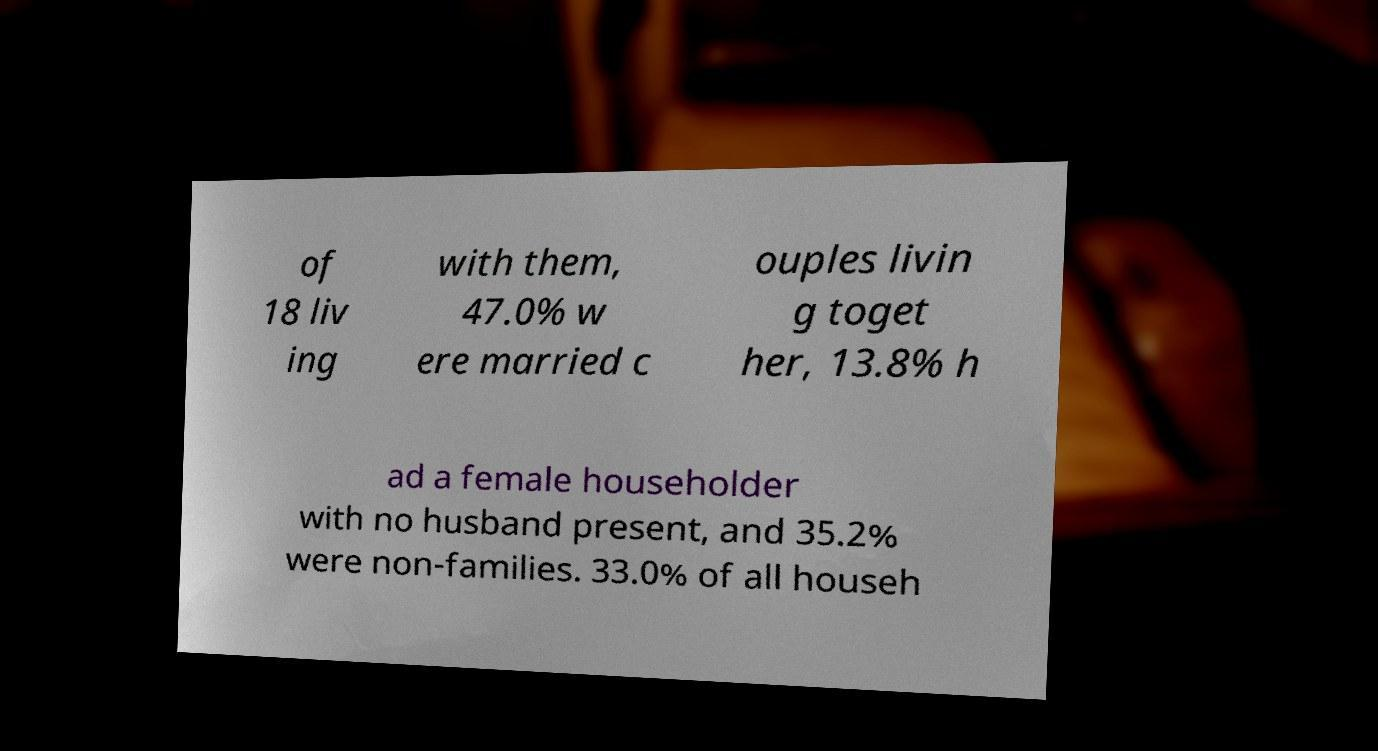Please read and relay the text visible in this image. What does it say? of 18 liv ing with them, 47.0% w ere married c ouples livin g toget her, 13.8% h ad a female householder with no husband present, and 35.2% were non-families. 33.0% of all househ 